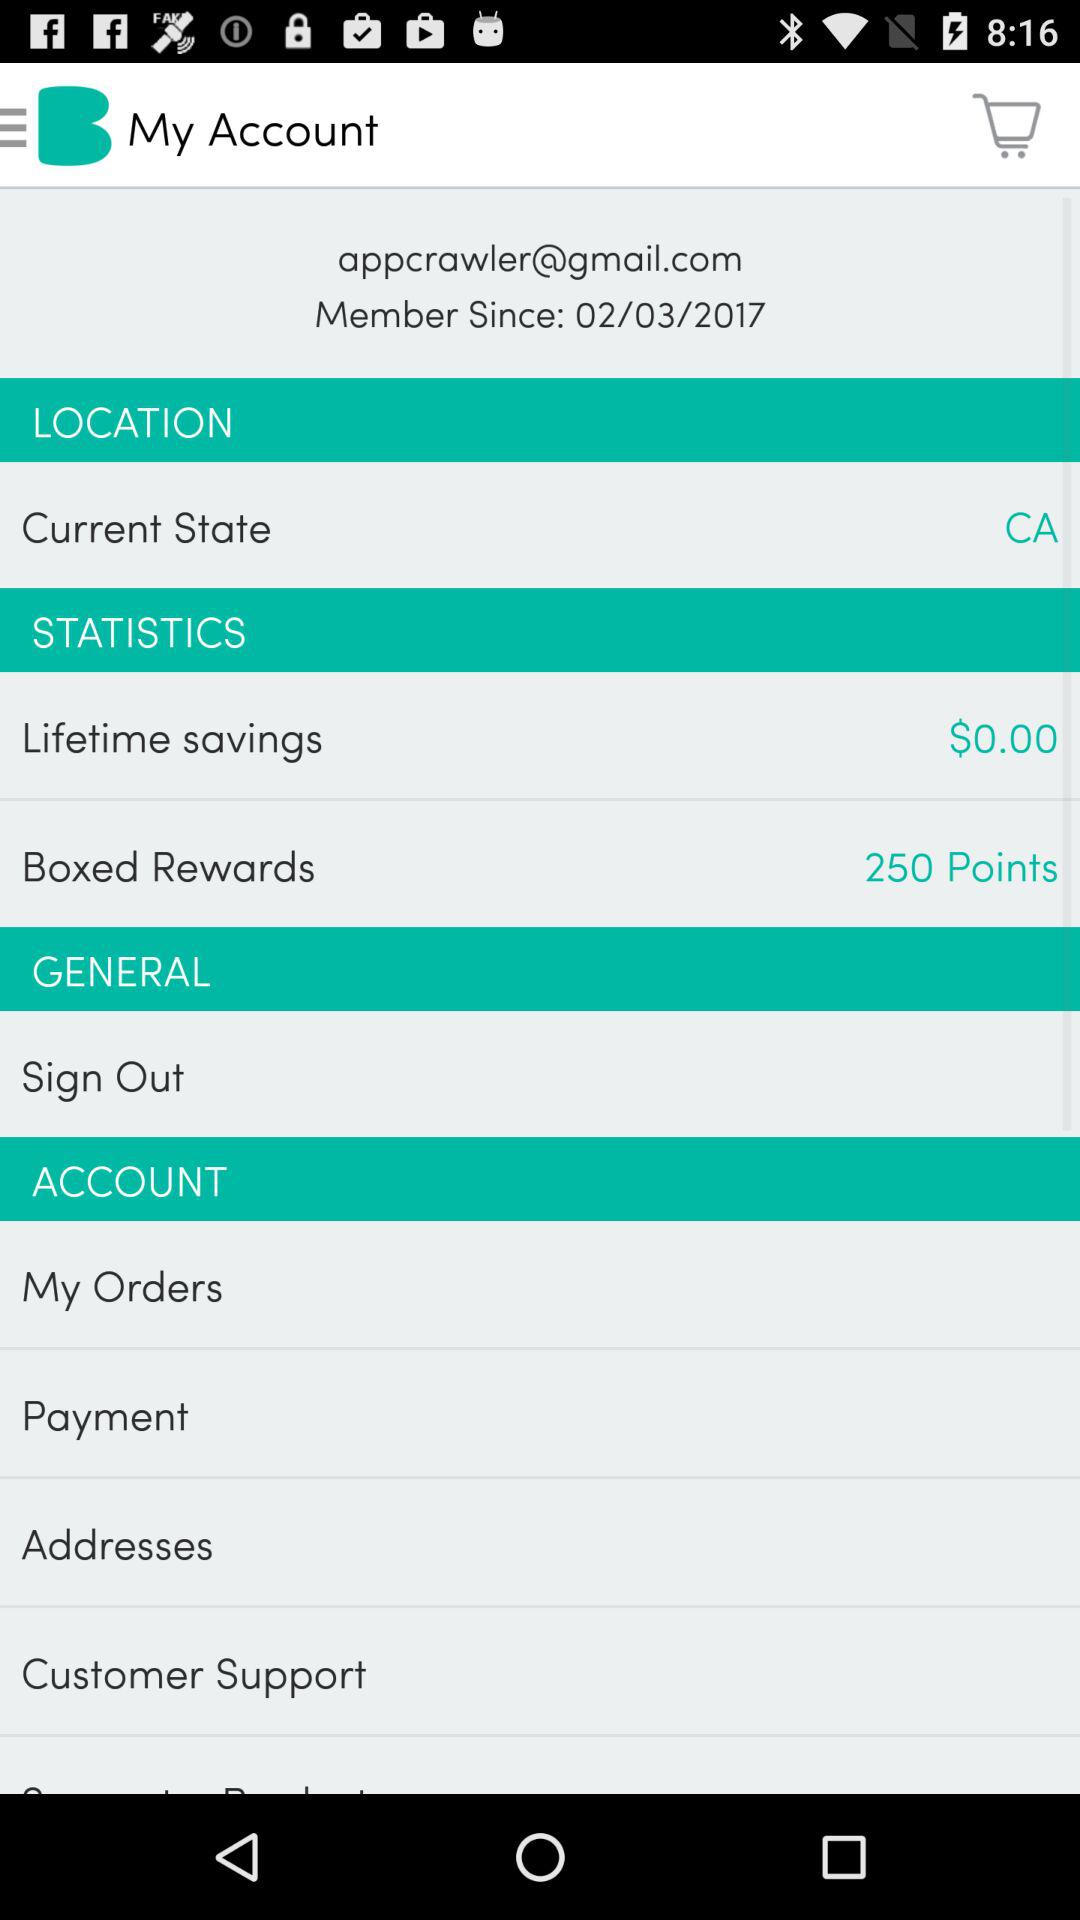What is the current state? The current state is California. 